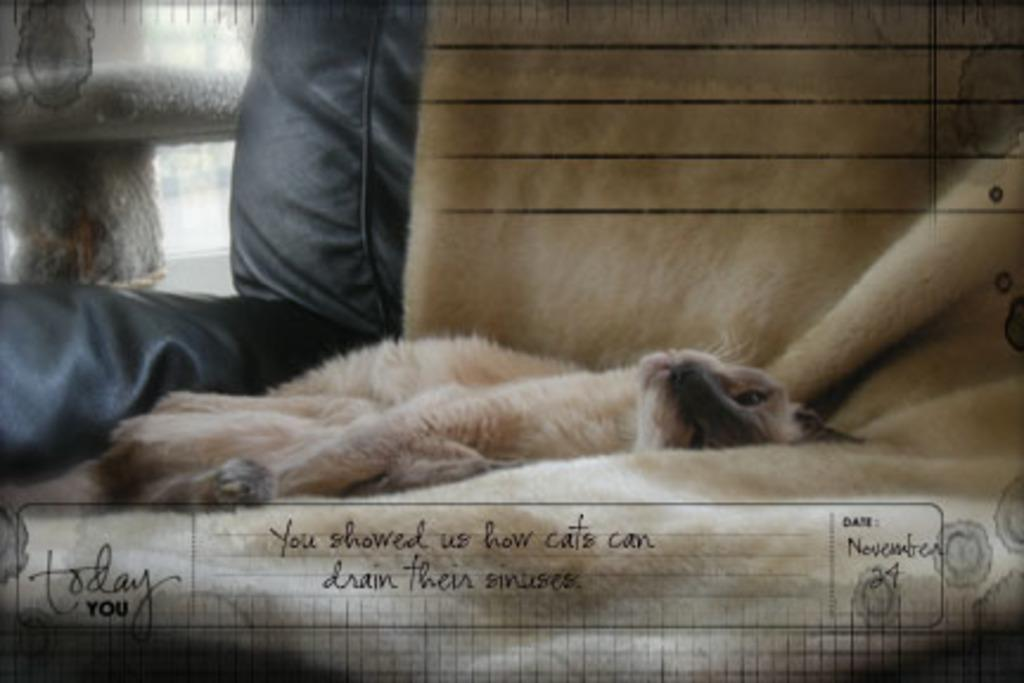What type of animal is in the image? There is a cat in the image. Where is the cat located? The cat is on a blanket. What else can be seen in the image besides the cat? There is some text visible beside the cat. What type of hall can be seen in the image? There is no hall present in the image; it features a cat on a blanket with some text beside it. What position does the range hold in the image? There is no range present in the image, so it cannot hold any position. 